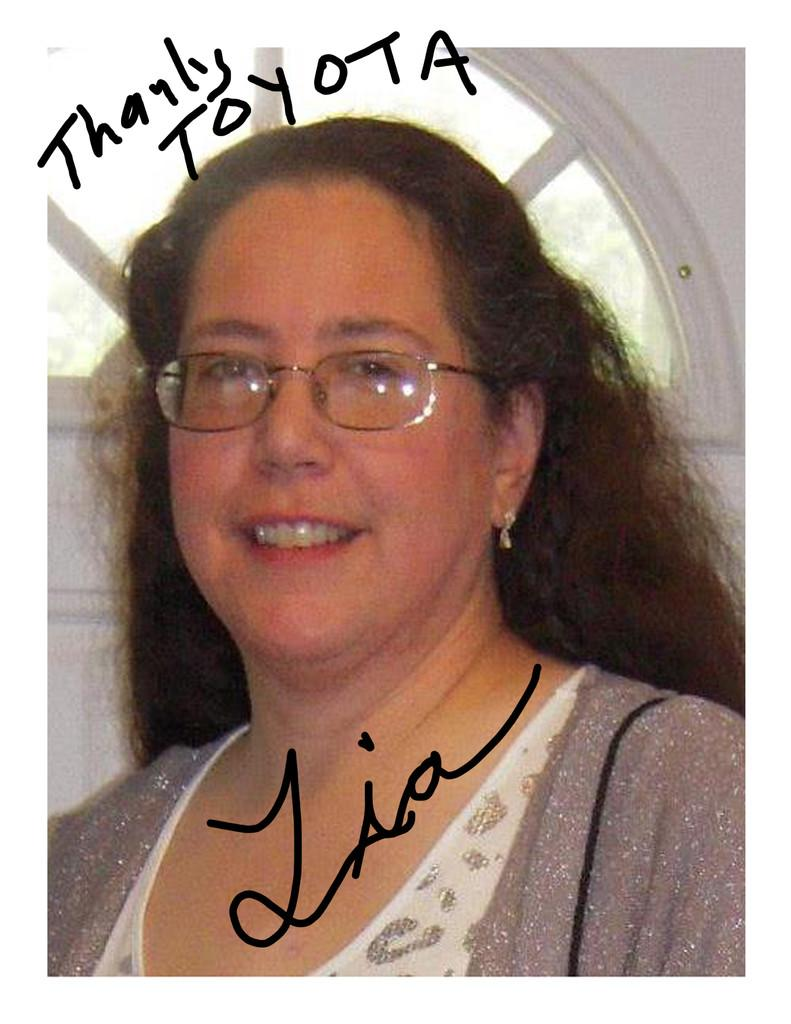Who is present in the image? There is a woman in the image. What is the woman's expression? The woman is smiling. What else can be seen in the image besides the woman? There is some text and trees in the background of the image. Can you describe the setting of the image? There is a window in the background of the image. What type of rule does the governor enforce in the image? There is no mention of a governor or any rules in the image; it features a woman smiling with some text and trees in the background. What color is the pickle on the woman's plate in the image? There is no pickle present in the image. 